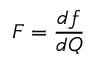<formula> <loc_0><loc_0><loc_500><loc_500>F = \frac { d f } { d Q }</formula> 